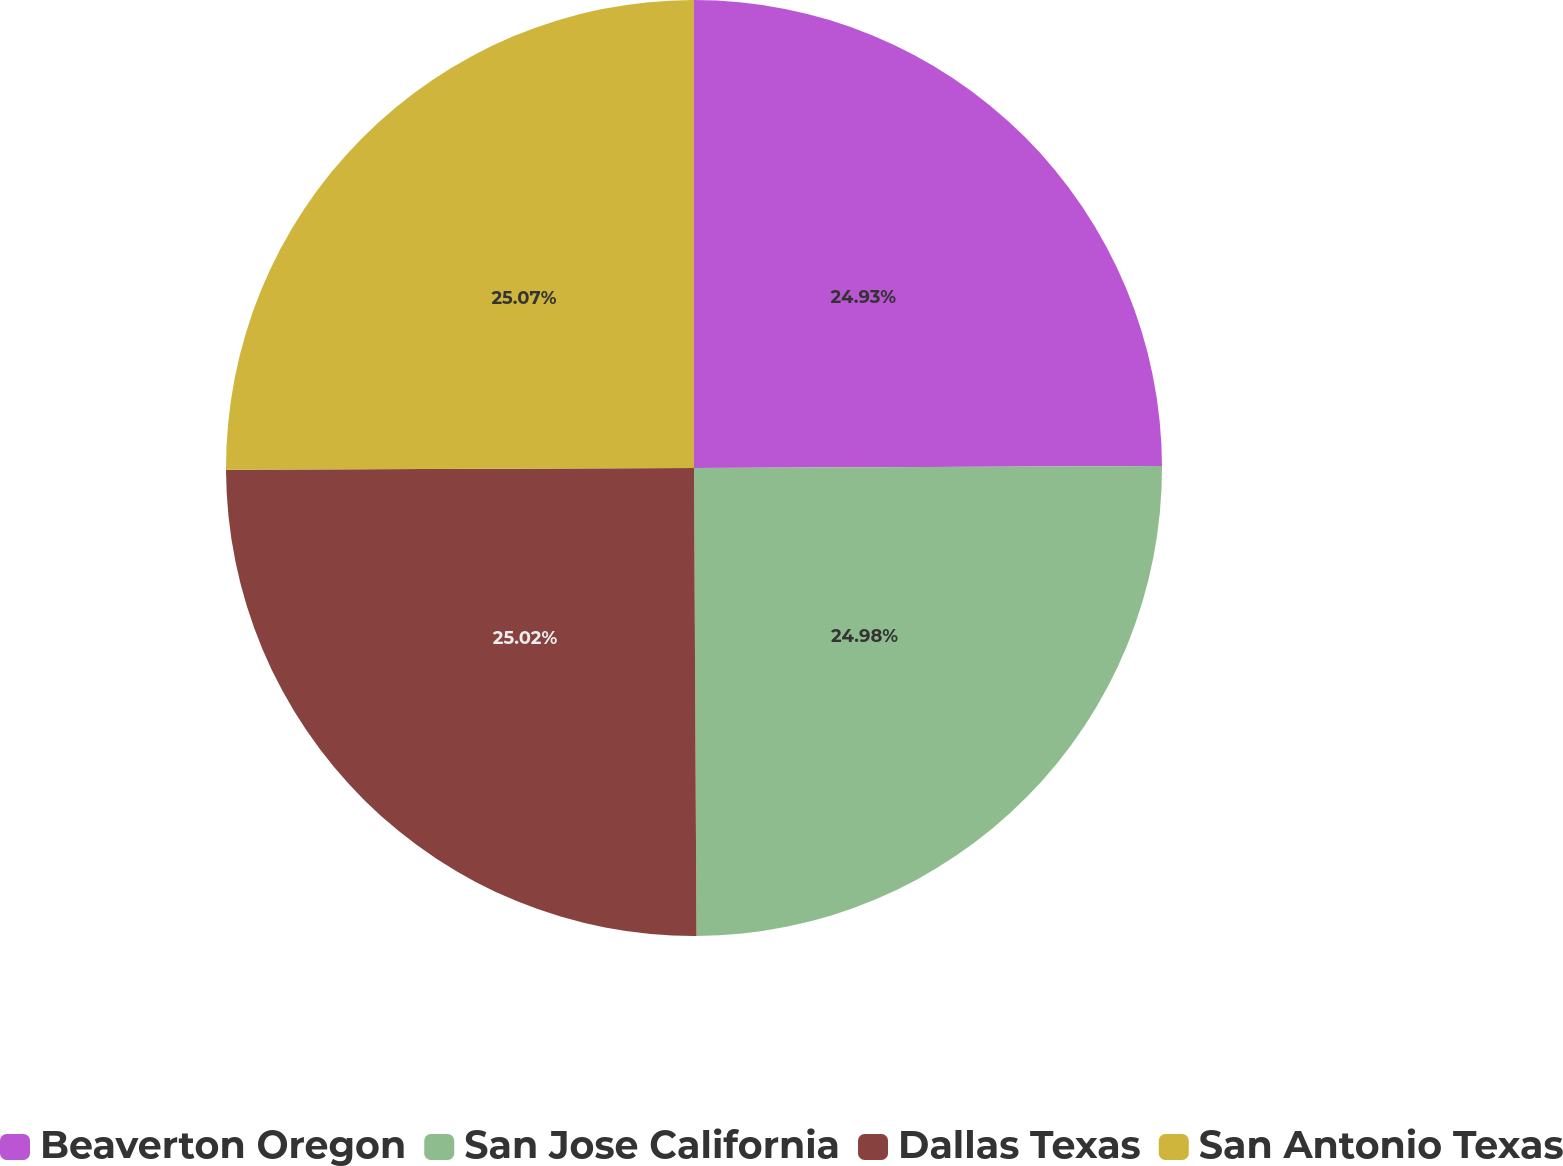Convert chart. <chart><loc_0><loc_0><loc_500><loc_500><pie_chart><fcel>Beaverton Oregon<fcel>San Jose California<fcel>Dallas Texas<fcel>San Antonio Texas<nl><fcel>24.93%<fcel>24.98%<fcel>25.02%<fcel>25.06%<nl></chart> 